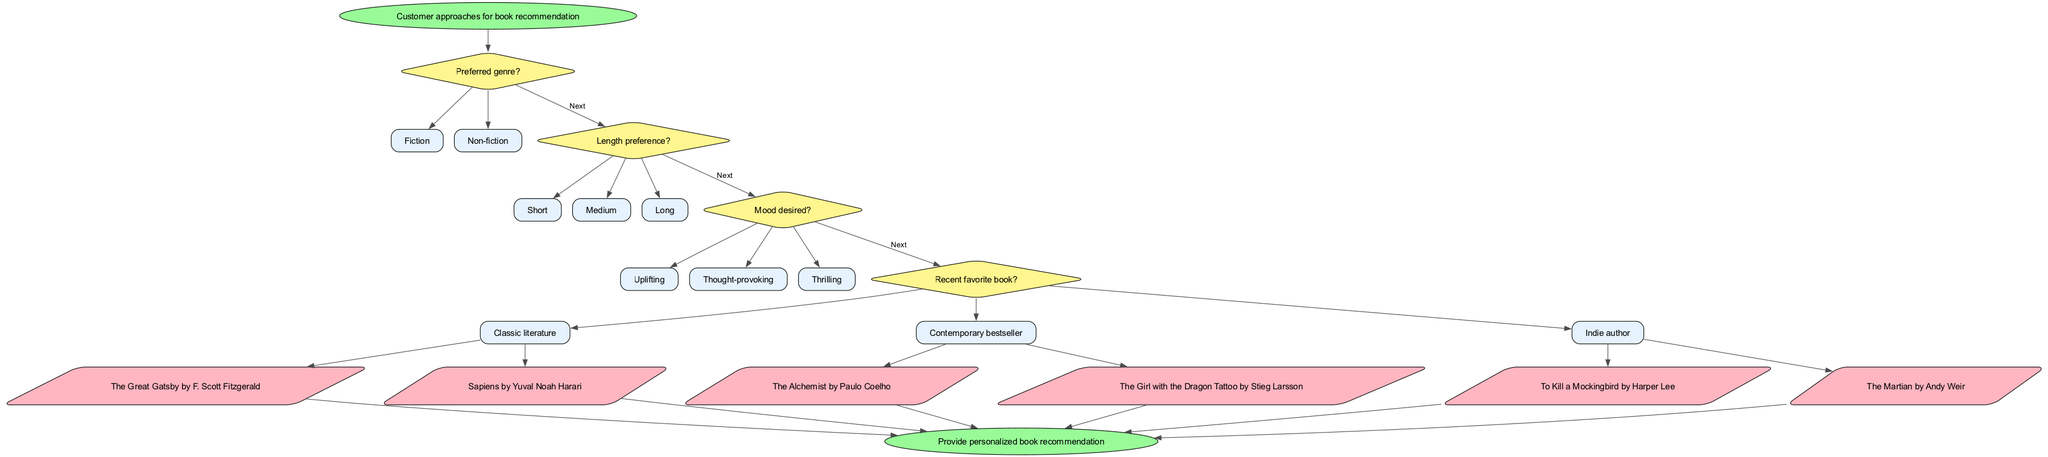What is the starting point of the flow chart? The flow chart begins with the node labeled "Customer approaches for book recommendation."
Answer: Customer approaches for book recommendation How many decision nodes are in the diagram? There are four decision nodes in the flow chart, each representing a question about preferences.
Answer: 4 What is the last recommendation node before ending the flow? The last recommendation node is labeled "The Martian by Andy Weir."
Answer: The Martian by Andy Weir What genre preference options does the flow chart provide? The flow chart provides two options under genre preference: "Fiction" and "Non-fiction."
Answer: Fiction, Non-fiction Which mood option leads to the recommendation of "The Girl with the Dragon Tattoo by Stieg Larsson"? The mood option "Thrilling" leads to the recommendation of "The Girl with the Dragon Tattoo by Stieg Larsson."
Answer: Thrilling If a customer prefers "Meduim" length, how many total recommendation options exist for that choice? The customer selecting "Medium" length would lead to three total recommendations, as the recommendation process provides one for each of the three mood options available.
Answer: 3 What decision comes after asking about the preferred genre? After asking about the preferred genre, the next decision pertains to the length preference of the book.
Answer: Length preference What color represents the decision nodes in the diagram? The decision nodes are represented in a color that is yellow, as shown in the flow chart.
Answer: Yellow What type of nodes are used for book recommendations? The nodes used for book recommendations are parallelograms, as indicated in the diagram.
Answer: Parallelograms 